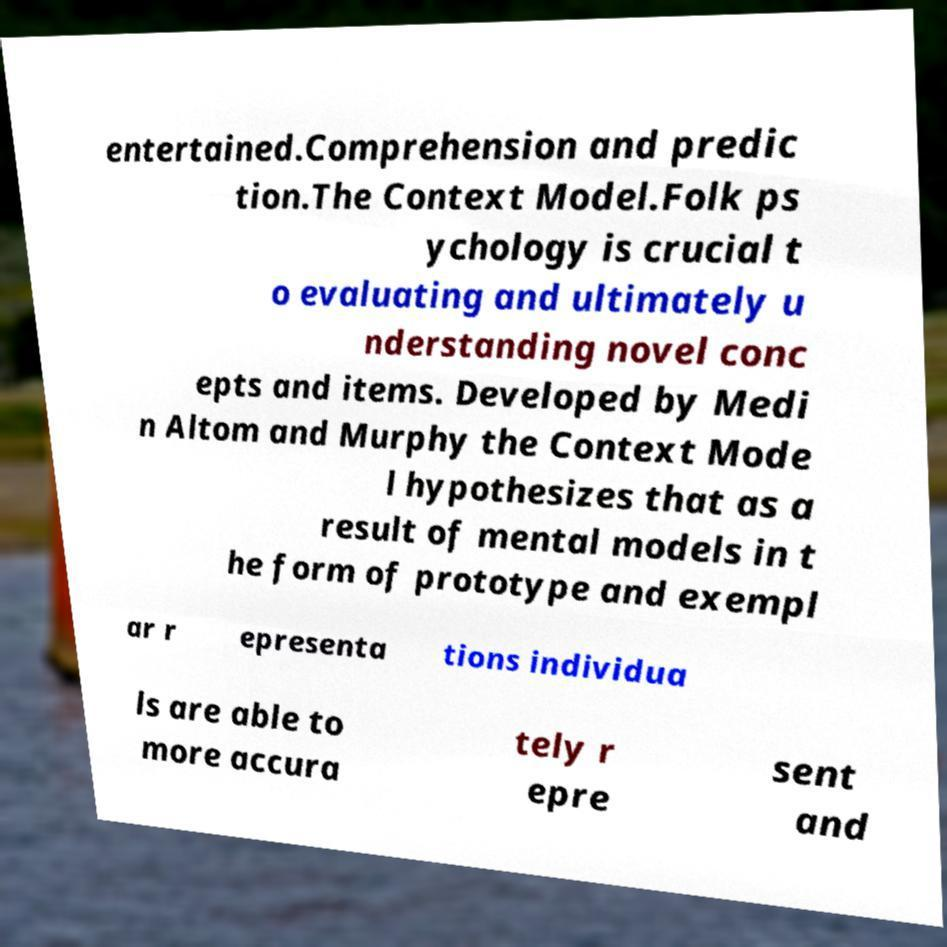Please read and relay the text visible in this image. What does it say? entertained.Comprehension and predic tion.The Context Model.Folk ps ychology is crucial t o evaluating and ultimately u nderstanding novel conc epts and items. Developed by Medi n Altom and Murphy the Context Mode l hypothesizes that as a result of mental models in t he form of prototype and exempl ar r epresenta tions individua ls are able to more accura tely r epre sent and 